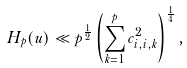Convert formula to latex. <formula><loc_0><loc_0><loc_500><loc_500>H _ { p } ( u ) \ll p ^ { \frac { 1 } { 2 } } \left ( \sum _ { k = 1 } ^ { p } c _ { i , i , k } ^ { 2 } \right ) ^ { \frac { 1 } { 4 } } ,</formula> 